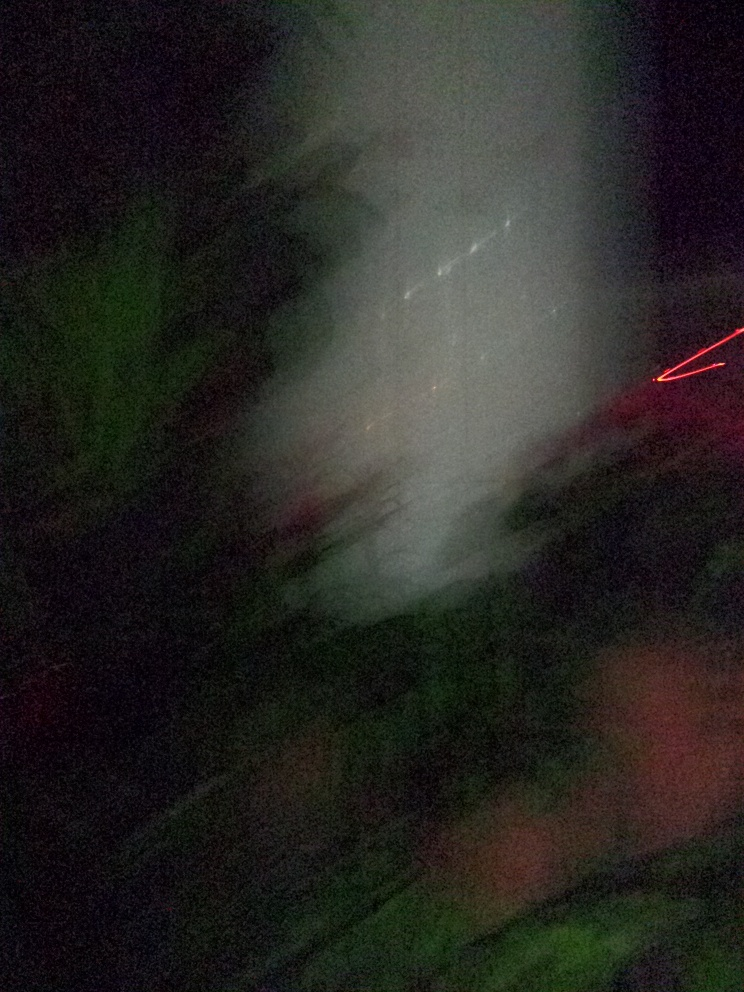Is there anything in this image that can be identified? Given the significant blurriness and abstract quality of the image, it's challenging to identify specific elements with confidence. However, there are hints of green that could suggest vegetation or foliage, and a streak of red light that might be a light source captured during motion. The white areas could be a result of overexposure or a light source within the scene. 